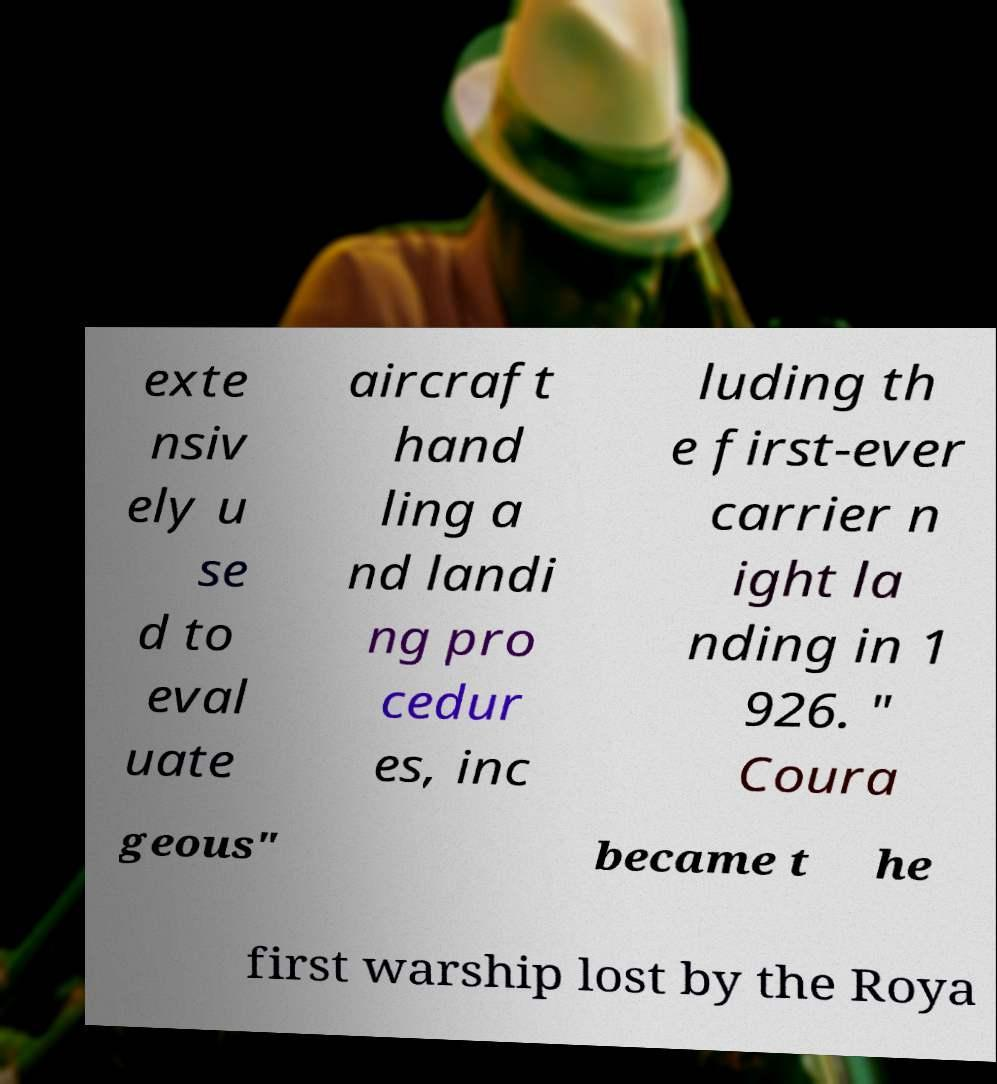For documentation purposes, I need the text within this image transcribed. Could you provide that? exte nsiv ely u se d to eval uate aircraft hand ling a nd landi ng pro cedur es, inc luding th e first-ever carrier n ight la nding in 1 926. " Coura geous" became t he first warship lost by the Roya 